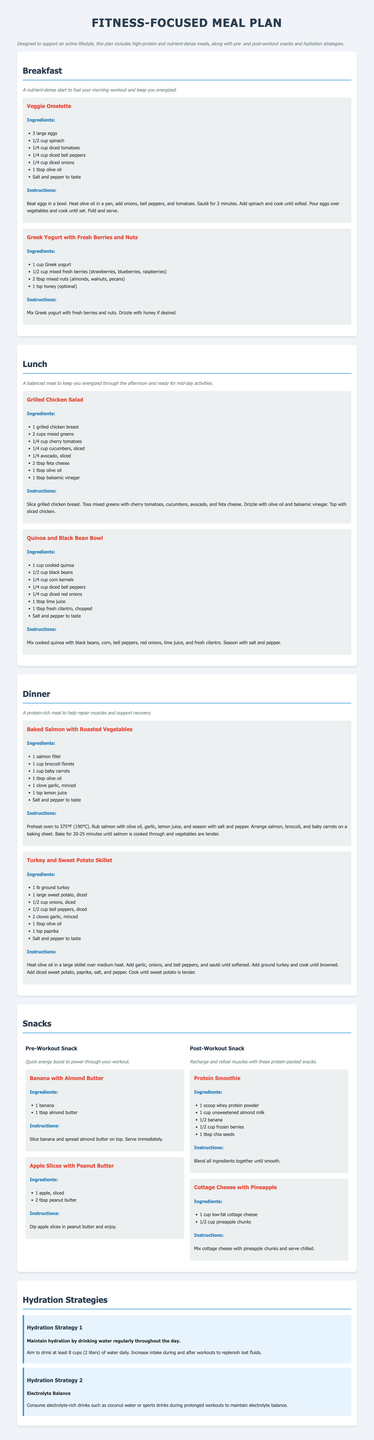What is the main focus of the meal plan? The meal plan is specifically designed to support an active lifestyle, which includes high-protein and nutrient-dense meals.
Answer: Active lifestyle How many large eggs are needed for the Veggie Omelette? The ingredients for the Veggie Omelette include 3 large eggs.
Answer: 3 large eggs What is a pre-workout snack option mentioned in the document? The pre-workout snacks listed include Banana with Almond Butter.
Answer: Banana with Almond Butter How many cups of water should one aim to drink daily? The hydration strategy advises to drink at least 8 cups (2 liters) of water daily.
Answer: 8 cups What ingredient is used to make the Grilled Chicken Salad dressing? The dressing for the Grilled Chicken Salad includes olive oil and balsamic vinegar.
Answer: Olive oil and balsamic vinegar What is the cooking temperature for the Baked Salmon? The instructions specify preheating the oven to 375°F (190°C) for the Baked Salmon.
Answer: 375°F How much protein powder is used in the Protein Smoothie? The Protein Smoothie recipe calls for 1 scoop of whey protein powder.
Answer: 1 scoop What type of cheese is included in the Quinoa and Black Bean Bowl? Feta cheese is included in the Grilled Chicken Salad, not the Quinoa and Black Bean Bowl.
Answer: Feta cheese What is the total number of meal sections in the document? The document includes four main meal sections: Breakfast, Lunch, Dinner, and Snacks.
Answer: Four sections 